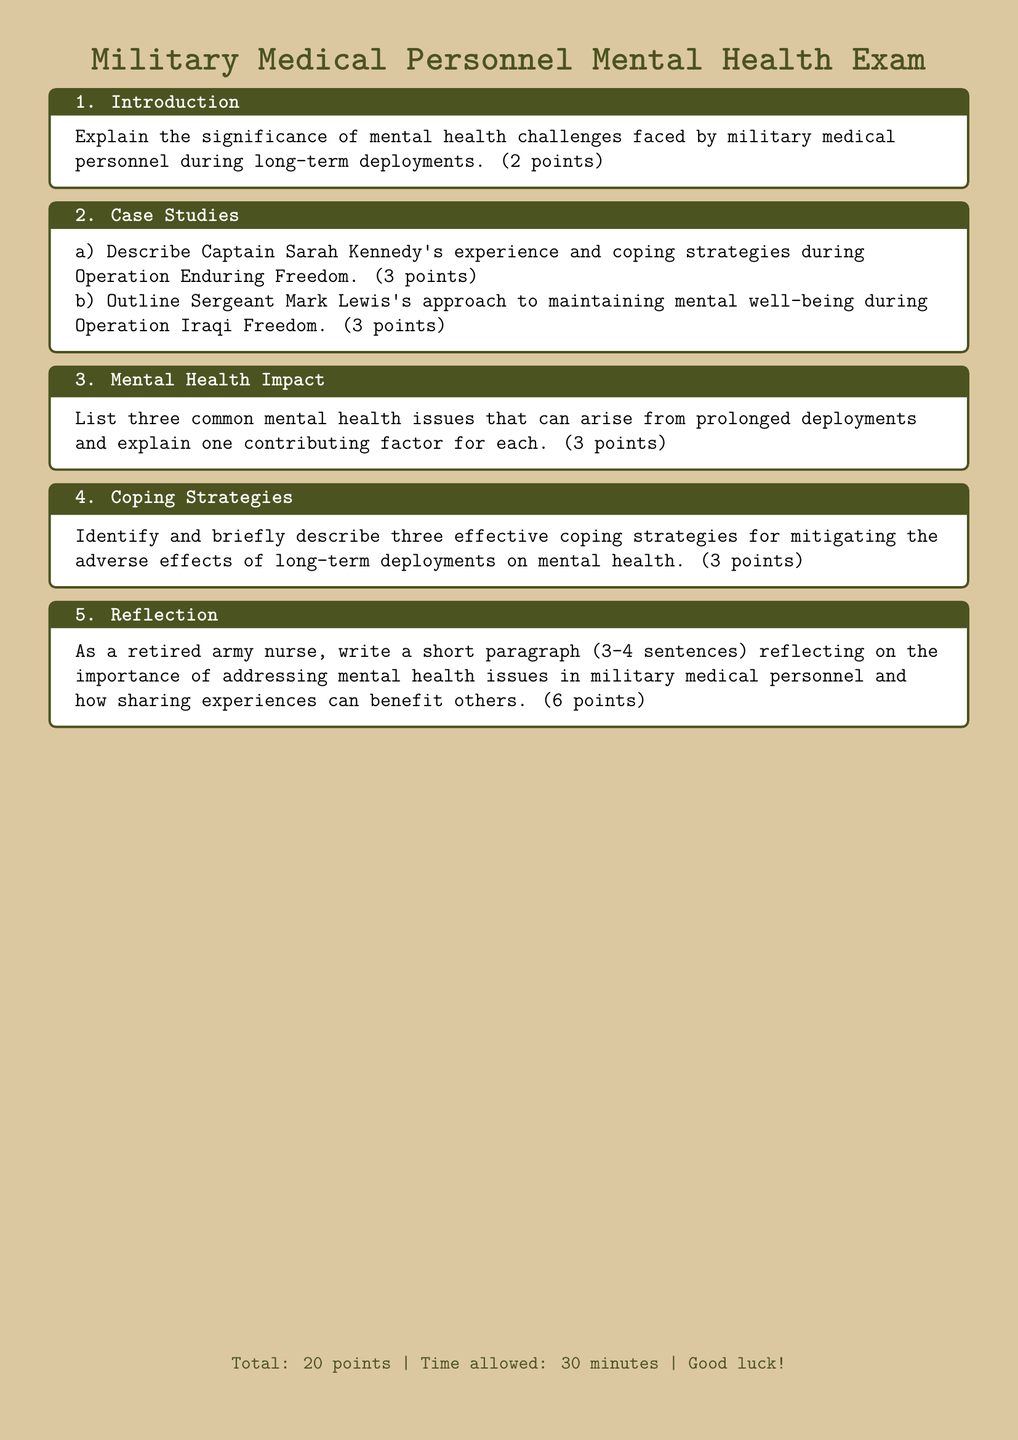What is the title of the exam? The title of the exam is presented at the top of the document, highlighting the focus on mental health in military medical personnel.
Answer: Military Medical Personnel Mental Health Exam How many points is the exam worth in total? The total points possible for the exam are noted at the bottom of the document, giving an overview of the evaluation criteria.
Answer: 20 points What is the time allowed for completing the exam? The time allowed for the exam is specified at the end of the document, indicating how long participants have to complete it.
Answer: 30 minutes What is the significance of mental health challenges according to the document? This section emphasizes the importance of understanding mental health issues faced by military medical staff during deployments.
Answer: (2 points) Who is Captain Sarah Kennedy? Captain Sarah Kennedy is mentioned as having had experiences during Operation Enduring Freedom, serving as a case study in the exam.
Answer: Captain Sarah Kennedy What is one of the case studies referred to in the exam? The case studies provided in the exam focus on specific military personnel and their experiences during deployments.
Answer: Captain Sarah Kennedy's experience How many coping strategies are to be identified for mitigating adverse effects? The exam specifically asks for a precise number of coping strategies that should be identified and described.
Answer: Three What reflects the importance of addressing mental health issues for military medical personnel? This reflection asks for personal insights related to the value of recognizing and discussing mental health challenges.
Answer: (3-4 sentences) What is one common mental health issue mentioned in the document? The document notes specific mental health issues that can develop as a result of prolonged deployments, highlighting significant concerns for personnel.
Answer: (e.g., PTSD) 